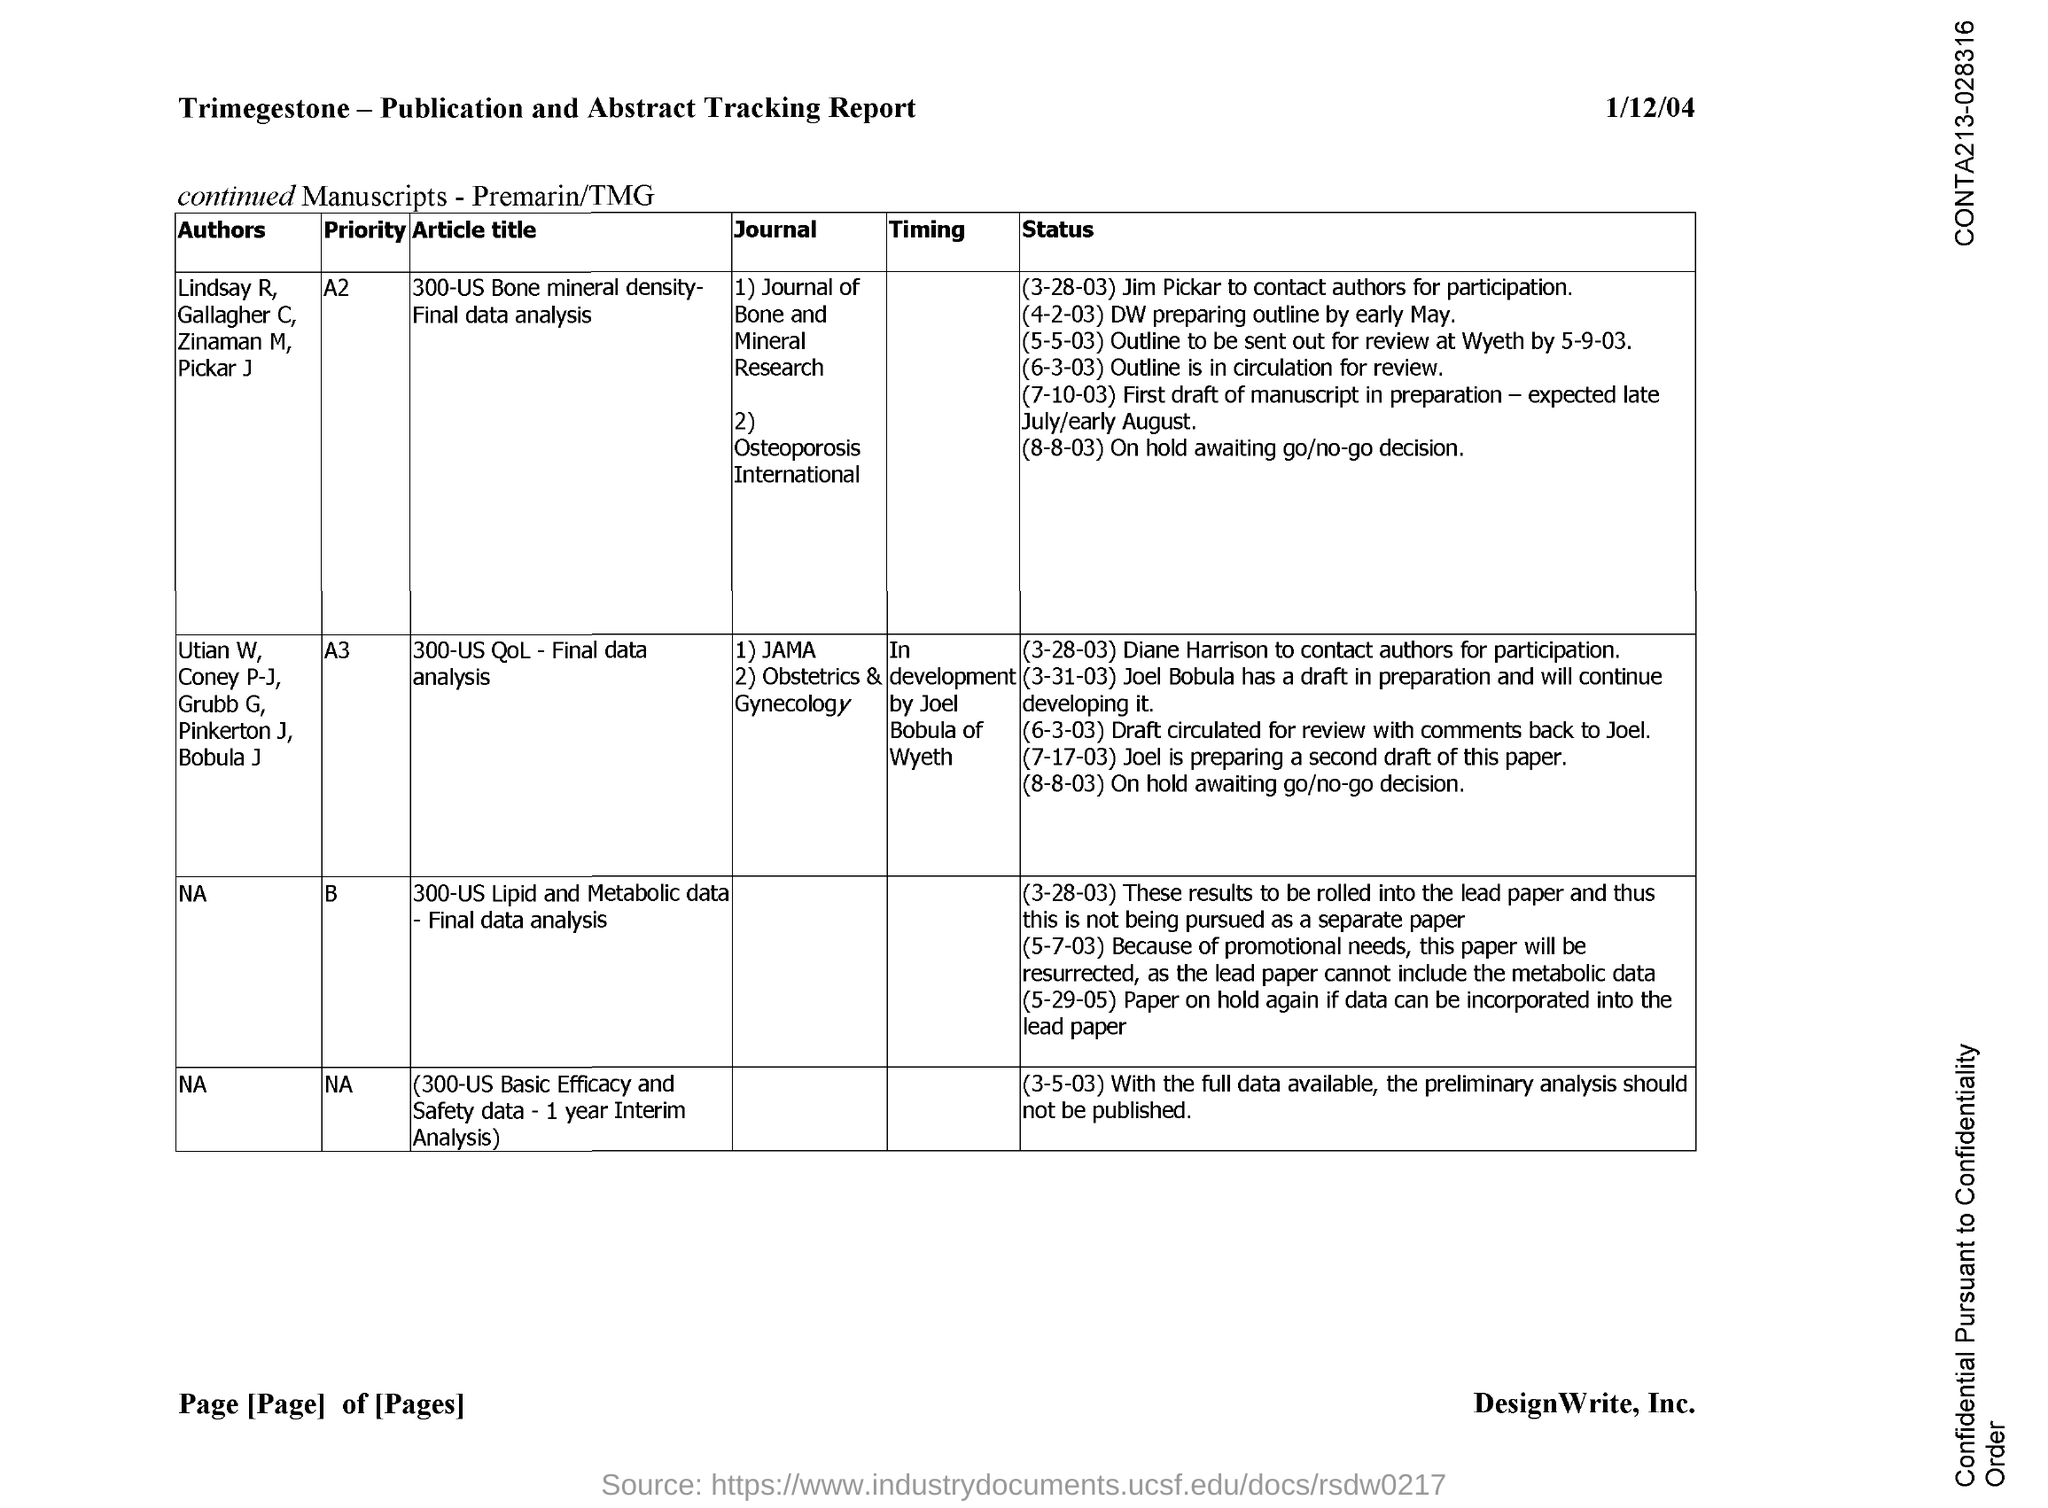What is the title of the document?
Ensure brevity in your answer.  Trimegestone - Publication and Abstract Tracking Report. What is the title of the article with priority A3?
Keep it short and to the point. 300-us qol-Final data analysis. 